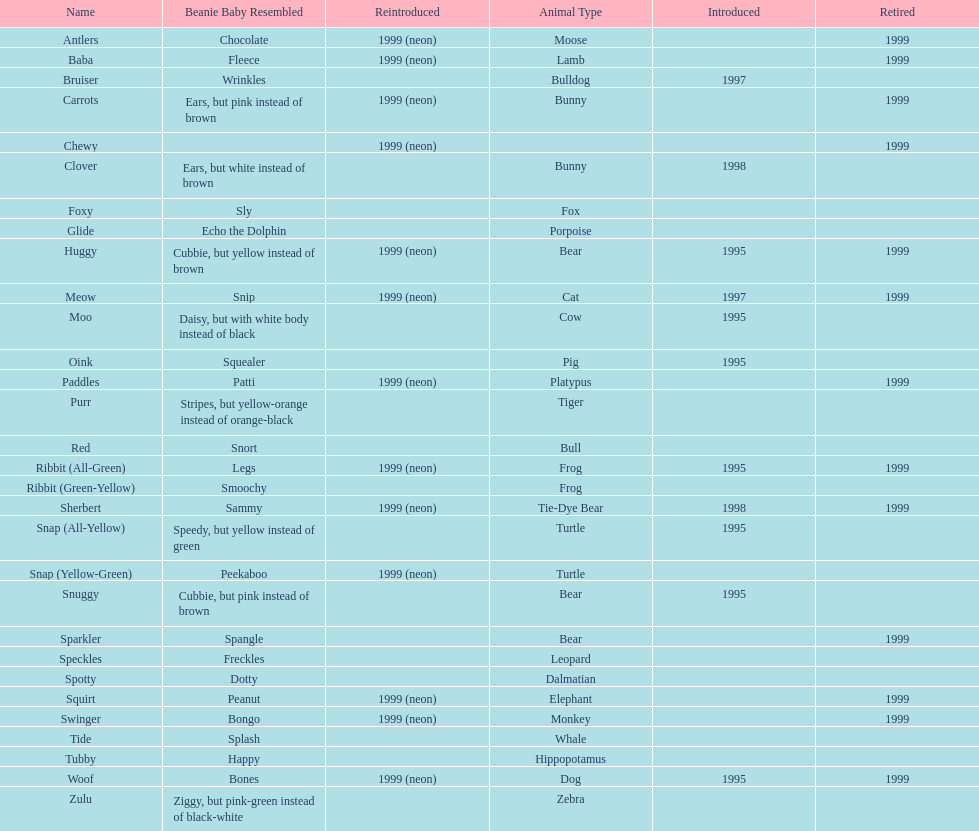Name the only pillow pal that is a dalmatian. Spotty. 